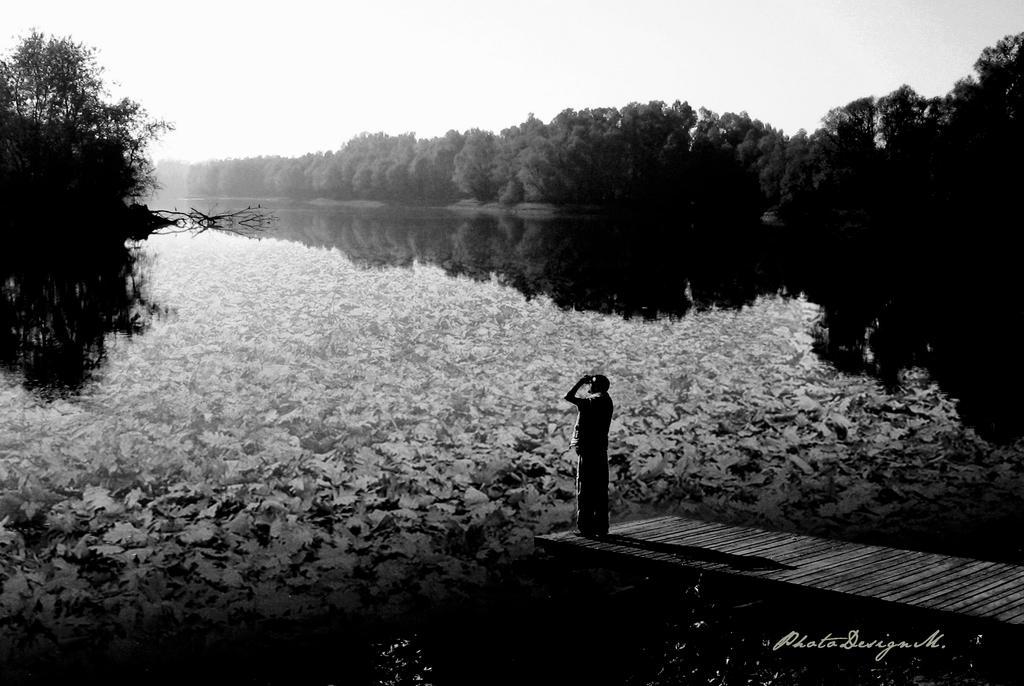Could you give a brief overview of what you see in this image? In this picture we can see water at the bottom, there are some trees in the background, we can see a man standing on the raft, there is the sky at the top of the picture, we can see text at the right bottom, it is a black and white picture. 